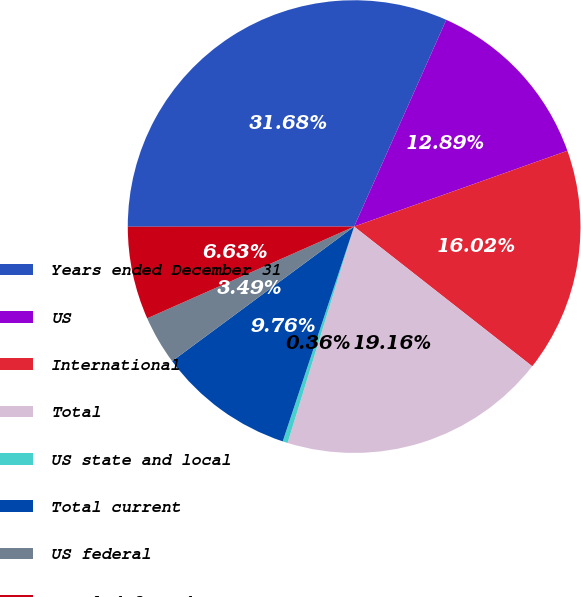<chart> <loc_0><loc_0><loc_500><loc_500><pie_chart><fcel>Years ended December 31<fcel>US<fcel>International<fcel>Total<fcel>US state and local<fcel>Total current<fcel>US federal<fcel>Total deferred<nl><fcel>31.68%<fcel>12.89%<fcel>16.02%<fcel>19.16%<fcel>0.36%<fcel>9.76%<fcel>3.49%<fcel>6.63%<nl></chart> 